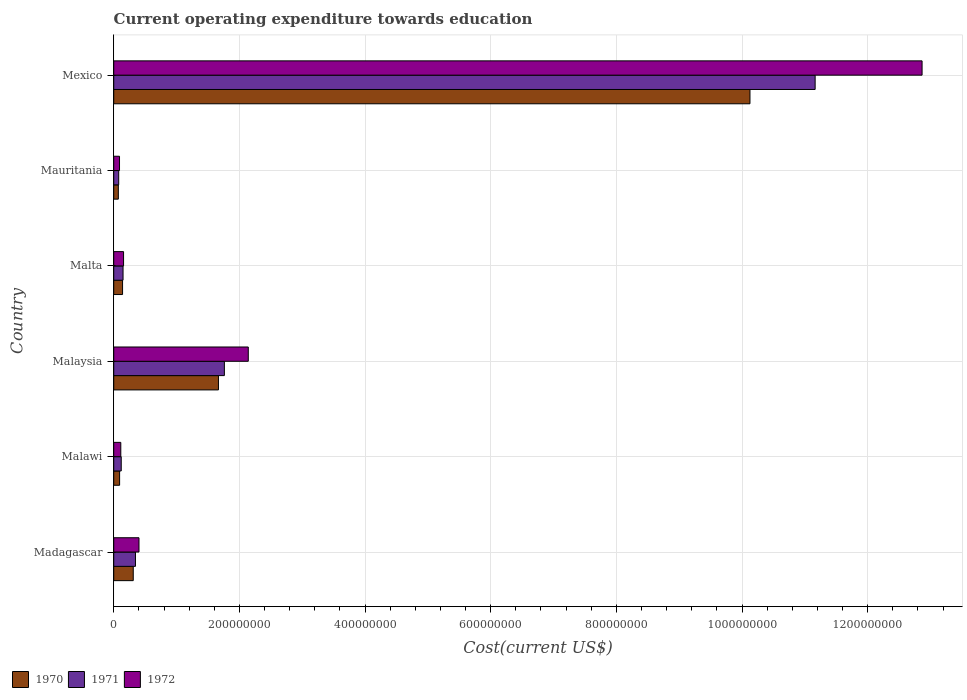How many different coloured bars are there?
Offer a very short reply. 3. Are the number of bars per tick equal to the number of legend labels?
Offer a very short reply. Yes. Are the number of bars on each tick of the Y-axis equal?
Your answer should be compact. Yes. What is the label of the 3rd group of bars from the top?
Keep it short and to the point. Malta. What is the expenditure towards education in 1971 in Malaysia?
Your answer should be very brief. 1.76e+08. Across all countries, what is the maximum expenditure towards education in 1970?
Offer a very short reply. 1.01e+09. Across all countries, what is the minimum expenditure towards education in 1971?
Give a very brief answer. 7.89e+06. In which country was the expenditure towards education in 1972 maximum?
Offer a very short reply. Mexico. In which country was the expenditure towards education in 1972 minimum?
Make the answer very short. Mauritania. What is the total expenditure towards education in 1970 in the graph?
Make the answer very short. 1.24e+09. What is the difference between the expenditure towards education in 1970 in Malaysia and that in Malta?
Keep it short and to the point. 1.53e+08. What is the difference between the expenditure towards education in 1971 in Malawi and the expenditure towards education in 1972 in Mauritania?
Ensure brevity in your answer.  2.73e+06. What is the average expenditure towards education in 1970 per country?
Offer a very short reply. 2.07e+08. What is the difference between the expenditure towards education in 1971 and expenditure towards education in 1972 in Mexico?
Your answer should be very brief. -1.70e+08. What is the ratio of the expenditure towards education in 1971 in Madagascar to that in Mauritania?
Your response must be concise. 4.38. Is the expenditure towards education in 1971 in Madagascar less than that in Malaysia?
Give a very brief answer. Yes. What is the difference between the highest and the second highest expenditure towards education in 1971?
Provide a short and direct response. 9.40e+08. What is the difference between the highest and the lowest expenditure towards education in 1970?
Give a very brief answer. 1.01e+09. Is the sum of the expenditure towards education in 1972 in Malaysia and Mexico greater than the maximum expenditure towards education in 1971 across all countries?
Provide a succinct answer. Yes. Is it the case that in every country, the sum of the expenditure towards education in 1971 and expenditure towards education in 1972 is greater than the expenditure towards education in 1970?
Make the answer very short. Yes. How many bars are there?
Offer a very short reply. 18. What is the difference between two consecutive major ticks on the X-axis?
Provide a short and direct response. 2.00e+08. Does the graph contain any zero values?
Your answer should be compact. No. Does the graph contain grids?
Provide a succinct answer. Yes. How are the legend labels stacked?
Give a very brief answer. Horizontal. What is the title of the graph?
Your response must be concise. Current operating expenditure towards education. Does "1973" appear as one of the legend labels in the graph?
Provide a succinct answer. No. What is the label or title of the X-axis?
Make the answer very short. Cost(current US$). What is the label or title of the Y-axis?
Make the answer very short. Country. What is the Cost(current US$) of 1970 in Madagascar?
Your answer should be very brief. 3.10e+07. What is the Cost(current US$) in 1971 in Madagascar?
Your answer should be very brief. 3.46e+07. What is the Cost(current US$) in 1972 in Madagascar?
Provide a short and direct response. 4.02e+07. What is the Cost(current US$) of 1970 in Malawi?
Your answer should be very brief. 9.35e+06. What is the Cost(current US$) in 1971 in Malawi?
Ensure brevity in your answer.  1.19e+07. What is the Cost(current US$) of 1972 in Malawi?
Ensure brevity in your answer.  1.12e+07. What is the Cost(current US$) in 1970 in Malaysia?
Ensure brevity in your answer.  1.67e+08. What is the Cost(current US$) of 1971 in Malaysia?
Your answer should be very brief. 1.76e+08. What is the Cost(current US$) of 1972 in Malaysia?
Provide a succinct answer. 2.14e+08. What is the Cost(current US$) in 1970 in Malta?
Your answer should be very brief. 1.40e+07. What is the Cost(current US$) of 1971 in Malta?
Your answer should be compact. 1.48e+07. What is the Cost(current US$) in 1972 in Malta?
Make the answer very short. 1.56e+07. What is the Cost(current US$) in 1970 in Mauritania?
Ensure brevity in your answer.  7.33e+06. What is the Cost(current US$) of 1971 in Mauritania?
Keep it short and to the point. 7.89e+06. What is the Cost(current US$) in 1972 in Mauritania?
Give a very brief answer. 9.19e+06. What is the Cost(current US$) in 1970 in Mexico?
Ensure brevity in your answer.  1.01e+09. What is the Cost(current US$) of 1971 in Mexico?
Keep it short and to the point. 1.12e+09. What is the Cost(current US$) in 1972 in Mexico?
Give a very brief answer. 1.29e+09. Across all countries, what is the maximum Cost(current US$) of 1970?
Your answer should be very brief. 1.01e+09. Across all countries, what is the maximum Cost(current US$) in 1971?
Provide a succinct answer. 1.12e+09. Across all countries, what is the maximum Cost(current US$) in 1972?
Provide a succinct answer. 1.29e+09. Across all countries, what is the minimum Cost(current US$) in 1970?
Your answer should be very brief. 7.33e+06. Across all countries, what is the minimum Cost(current US$) of 1971?
Ensure brevity in your answer.  7.89e+06. Across all countries, what is the minimum Cost(current US$) in 1972?
Offer a terse response. 9.19e+06. What is the total Cost(current US$) of 1970 in the graph?
Give a very brief answer. 1.24e+09. What is the total Cost(current US$) of 1971 in the graph?
Offer a very short reply. 1.36e+09. What is the total Cost(current US$) of 1972 in the graph?
Your response must be concise. 1.58e+09. What is the difference between the Cost(current US$) in 1970 in Madagascar and that in Malawi?
Your answer should be compact. 2.17e+07. What is the difference between the Cost(current US$) in 1971 in Madagascar and that in Malawi?
Your answer should be compact. 2.27e+07. What is the difference between the Cost(current US$) in 1972 in Madagascar and that in Malawi?
Provide a short and direct response. 2.89e+07. What is the difference between the Cost(current US$) in 1970 in Madagascar and that in Malaysia?
Offer a very short reply. -1.36e+08. What is the difference between the Cost(current US$) of 1971 in Madagascar and that in Malaysia?
Make the answer very short. -1.42e+08. What is the difference between the Cost(current US$) in 1972 in Madagascar and that in Malaysia?
Ensure brevity in your answer.  -1.74e+08. What is the difference between the Cost(current US$) in 1970 in Madagascar and that in Malta?
Keep it short and to the point. 1.70e+07. What is the difference between the Cost(current US$) of 1971 in Madagascar and that in Malta?
Give a very brief answer. 1.98e+07. What is the difference between the Cost(current US$) in 1972 in Madagascar and that in Malta?
Give a very brief answer. 2.45e+07. What is the difference between the Cost(current US$) of 1970 in Madagascar and that in Mauritania?
Give a very brief answer. 2.37e+07. What is the difference between the Cost(current US$) in 1971 in Madagascar and that in Mauritania?
Make the answer very short. 2.67e+07. What is the difference between the Cost(current US$) of 1972 in Madagascar and that in Mauritania?
Keep it short and to the point. 3.10e+07. What is the difference between the Cost(current US$) of 1970 in Madagascar and that in Mexico?
Ensure brevity in your answer.  -9.82e+08. What is the difference between the Cost(current US$) of 1971 in Madagascar and that in Mexico?
Offer a very short reply. -1.08e+09. What is the difference between the Cost(current US$) of 1972 in Madagascar and that in Mexico?
Provide a short and direct response. -1.25e+09. What is the difference between the Cost(current US$) of 1970 in Malawi and that in Malaysia?
Provide a short and direct response. -1.57e+08. What is the difference between the Cost(current US$) in 1971 in Malawi and that in Malaysia?
Keep it short and to the point. -1.64e+08. What is the difference between the Cost(current US$) in 1972 in Malawi and that in Malaysia?
Ensure brevity in your answer.  -2.03e+08. What is the difference between the Cost(current US$) in 1970 in Malawi and that in Malta?
Give a very brief answer. -4.69e+06. What is the difference between the Cost(current US$) in 1971 in Malawi and that in Malta?
Keep it short and to the point. -2.89e+06. What is the difference between the Cost(current US$) in 1972 in Malawi and that in Malta?
Keep it short and to the point. -4.40e+06. What is the difference between the Cost(current US$) of 1970 in Malawi and that in Mauritania?
Offer a very short reply. 2.02e+06. What is the difference between the Cost(current US$) of 1971 in Malawi and that in Mauritania?
Offer a terse response. 4.04e+06. What is the difference between the Cost(current US$) in 1972 in Malawi and that in Mauritania?
Keep it short and to the point. 2.05e+06. What is the difference between the Cost(current US$) in 1970 in Malawi and that in Mexico?
Ensure brevity in your answer.  -1.00e+09. What is the difference between the Cost(current US$) of 1971 in Malawi and that in Mexico?
Provide a succinct answer. -1.10e+09. What is the difference between the Cost(current US$) of 1972 in Malawi and that in Mexico?
Ensure brevity in your answer.  -1.28e+09. What is the difference between the Cost(current US$) of 1970 in Malaysia and that in Malta?
Give a very brief answer. 1.53e+08. What is the difference between the Cost(current US$) of 1971 in Malaysia and that in Malta?
Your response must be concise. 1.61e+08. What is the difference between the Cost(current US$) of 1972 in Malaysia and that in Malta?
Offer a very short reply. 1.98e+08. What is the difference between the Cost(current US$) in 1970 in Malaysia and that in Mauritania?
Provide a short and direct response. 1.59e+08. What is the difference between the Cost(current US$) of 1971 in Malaysia and that in Mauritania?
Your response must be concise. 1.68e+08. What is the difference between the Cost(current US$) in 1972 in Malaysia and that in Mauritania?
Give a very brief answer. 2.05e+08. What is the difference between the Cost(current US$) in 1970 in Malaysia and that in Mexico?
Offer a very short reply. -8.46e+08. What is the difference between the Cost(current US$) of 1971 in Malaysia and that in Mexico?
Give a very brief answer. -9.40e+08. What is the difference between the Cost(current US$) in 1972 in Malaysia and that in Mexico?
Provide a succinct answer. -1.07e+09. What is the difference between the Cost(current US$) of 1970 in Malta and that in Mauritania?
Provide a short and direct response. 6.71e+06. What is the difference between the Cost(current US$) of 1971 in Malta and that in Mauritania?
Make the answer very short. 6.93e+06. What is the difference between the Cost(current US$) in 1972 in Malta and that in Mauritania?
Your answer should be compact. 6.45e+06. What is the difference between the Cost(current US$) of 1970 in Malta and that in Mexico?
Give a very brief answer. -9.99e+08. What is the difference between the Cost(current US$) of 1971 in Malta and that in Mexico?
Ensure brevity in your answer.  -1.10e+09. What is the difference between the Cost(current US$) of 1972 in Malta and that in Mexico?
Make the answer very short. -1.27e+09. What is the difference between the Cost(current US$) in 1970 in Mauritania and that in Mexico?
Give a very brief answer. -1.01e+09. What is the difference between the Cost(current US$) of 1971 in Mauritania and that in Mexico?
Your answer should be compact. -1.11e+09. What is the difference between the Cost(current US$) of 1972 in Mauritania and that in Mexico?
Offer a very short reply. -1.28e+09. What is the difference between the Cost(current US$) of 1970 in Madagascar and the Cost(current US$) of 1971 in Malawi?
Ensure brevity in your answer.  1.91e+07. What is the difference between the Cost(current US$) of 1970 in Madagascar and the Cost(current US$) of 1972 in Malawi?
Your response must be concise. 1.98e+07. What is the difference between the Cost(current US$) of 1971 in Madagascar and the Cost(current US$) of 1972 in Malawi?
Your answer should be compact. 2.34e+07. What is the difference between the Cost(current US$) in 1970 in Madagascar and the Cost(current US$) in 1971 in Malaysia?
Provide a short and direct response. -1.45e+08. What is the difference between the Cost(current US$) of 1970 in Madagascar and the Cost(current US$) of 1972 in Malaysia?
Your answer should be very brief. -1.83e+08. What is the difference between the Cost(current US$) in 1971 in Madagascar and the Cost(current US$) in 1972 in Malaysia?
Provide a short and direct response. -1.80e+08. What is the difference between the Cost(current US$) in 1970 in Madagascar and the Cost(current US$) in 1971 in Malta?
Make the answer very short. 1.62e+07. What is the difference between the Cost(current US$) in 1970 in Madagascar and the Cost(current US$) in 1972 in Malta?
Offer a terse response. 1.54e+07. What is the difference between the Cost(current US$) of 1971 in Madagascar and the Cost(current US$) of 1972 in Malta?
Your answer should be compact. 1.90e+07. What is the difference between the Cost(current US$) of 1970 in Madagascar and the Cost(current US$) of 1971 in Mauritania?
Offer a very short reply. 2.32e+07. What is the difference between the Cost(current US$) of 1970 in Madagascar and the Cost(current US$) of 1972 in Mauritania?
Your response must be concise. 2.19e+07. What is the difference between the Cost(current US$) in 1971 in Madagascar and the Cost(current US$) in 1972 in Mauritania?
Your answer should be very brief. 2.54e+07. What is the difference between the Cost(current US$) in 1970 in Madagascar and the Cost(current US$) in 1971 in Mexico?
Make the answer very short. -1.09e+09. What is the difference between the Cost(current US$) of 1970 in Madagascar and the Cost(current US$) of 1972 in Mexico?
Your answer should be very brief. -1.26e+09. What is the difference between the Cost(current US$) in 1971 in Madagascar and the Cost(current US$) in 1972 in Mexico?
Keep it short and to the point. -1.25e+09. What is the difference between the Cost(current US$) of 1970 in Malawi and the Cost(current US$) of 1971 in Malaysia?
Give a very brief answer. -1.67e+08. What is the difference between the Cost(current US$) in 1970 in Malawi and the Cost(current US$) in 1972 in Malaysia?
Keep it short and to the point. -2.05e+08. What is the difference between the Cost(current US$) of 1971 in Malawi and the Cost(current US$) of 1972 in Malaysia?
Offer a very short reply. -2.02e+08. What is the difference between the Cost(current US$) of 1970 in Malawi and the Cost(current US$) of 1971 in Malta?
Your response must be concise. -5.47e+06. What is the difference between the Cost(current US$) of 1970 in Malawi and the Cost(current US$) of 1972 in Malta?
Make the answer very short. -6.29e+06. What is the difference between the Cost(current US$) in 1971 in Malawi and the Cost(current US$) in 1972 in Malta?
Give a very brief answer. -3.71e+06. What is the difference between the Cost(current US$) in 1970 in Malawi and the Cost(current US$) in 1971 in Mauritania?
Give a very brief answer. 1.46e+06. What is the difference between the Cost(current US$) in 1970 in Malawi and the Cost(current US$) in 1972 in Mauritania?
Give a very brief answer. 1.55e+05. What is the difference between the Cost(current US$) of 1971 in Malawi and the Cost(current US$) of 1972 in Mauritania?
Provide a succinct answer. 2.73e+06. What is the difference between the Cost(current US$) in 1970 in Malawi and the Cost(current US$) in 1971 in Mexico?
Provide a succinct answer. -1.11e+09. What is the difference between the Cost(current US$) of 1970 in Malawi and the Cost(current US$) of 1972 in Mexico?
Offer a terse response. -1.28e+09. What is the difference between the Cost(current US$) of 1971 in Malawi and the Cost(current US$) of 1972 in Mexico?
Offer a very short reply. -1.27e+09. What is the difference between the Cost(current US$) of 1970 in Malaysia and the Cost(current US$) of 1971 in Malta?
Your answer should be compact. 1.52e+08. What is the difference between the Cost(current US$) of 1970 in Malaysia and the Cost(current US$) of 1972 in Malta?
Provide a succinct answer. 1.51e+08. What is the difference between the Cost(current US$) of 1971 in Malaysia and the Cost(current US$) of 1972 in Malta?
Make the answer very short. 1.60e+08. What is the difference between the Cost(current US$) in 1970 in Malaysia and the Cost(current US$) in 1971 in Mauritania?
Make the answer very short. 1.59e+08. What is the difference between the Cost(current US$) of 1970 in Malaysia and the Cost(current US$) of 1972 in Mauritania?
Offer a terse response. 1.57e+08. What is the difference between the Cost(current US$) of 1971 in Malaysia and the Cost(current US$) of 1972 in Mauritania?
Make the answer very short. 1.67e+08. What is the difference between the Cost(current US$) of 1970 in Malaysia and the Cost(current US$) of 1971 in Mexico?
Your answer should be very brief. -9.50e+08. What is the difference between the Cost(current US$) of 1970 in Malaysia and the Cost(current US$) of 1972 in Mexico?
Give a very brief answer. -1.12e+09. What is the difference between the Cost(current US$) in 1971 in Malaysia and the Cost(current US$) in 1972 in Mexico?
Provide a succinct answer. -1.11e+09. What is the difference between the Cost(current US$) in 1970 in Malta and the Cost(current US$) in 1971 in Mauritania?
Provide a short and direct response. 6.15e+06. What is the difference between the Cost(current US$) in 1970 in Malta and the Cost(current US$) in 1972 in Mauritania?
Provide a succinct answer. 4.85e+06. What is the difference between the Cost(current US$) in 1971 in Malta and the Cost(current US$) in 1972 in Mauritania?
Offer a very short reply. 5.62e+06. What is the difference between the Cost(current US$) in 1970 in Malta and the Cost(current US$) in 1971 in Mexico?
Your response must be concise. -1.10e+09. What is the difference between the Cost(current US$) of 1970 in Malta and the Cost(current US$) of 1972 in Mexico?
Provide a short and direct response. -1.27e+09. What is the difference between the Cost(current US$) of 1971 in Malta and the Cost(current US$) of 1972 in Mexico?
Your response must be concise. -1.27e+09. What is the difference between the Cost(current US$) of 1970 in Mauritania and the Cost(current US$) of 1971 in Mexico?
Make the answer very short. -1.11e+09. What is the difference between the Cost(current US$) in 1970 in Mauritania and the Cost(current US$) in 1972 in Mexico?
Your response must be concise. -1.28e+09. What is the difference between the Cost(current US$) in 1971 in Mauritania and the Cost(current US$) in 1972 in Mexico?
Your answer should be compact. -1.28e+09. What is the average Cost(current US$) of 1970 per country?
Your answer should be very brief. 2.07e+08. What is the average Cost(current US$) in 1971 per country?
Offer a terse response. 2.27e+08. What is the average Cost(current US$) in 1972 per country?
Your answer should be compact. 2.63e+08. What is the difference between the Cost(current US$) in 1970 and Cost(current US$) in 1971 in Madagascar?
Make the answer very short. -3.55e+06. What is the difference between the Cost(current US$) of 1970 and Cost(current US$) of 1972 in Madagascar?
Offer a very short reply. -9.14e+06. What is the difference between the Cost(current US$) in 1971 and Cost(current US$) in 1972 in Madagascar?
Provide a short and direct response. -5.59e+06. What is the difference between the Cost(current US$) of 1970 and Cost(current US$) of 1971 in Malawi?
Your answer should be compact. -2.58e+06. What is the difference between the Cost(current US$) in 1970 and Cost(current US$) in 1972 in Malawi?
Your answer should be very brief. -1.89e+06. What is the difference between the Cost(current US$) of 1971 and Cost(current US$) of 1972 in Malawi?
Your response must be concise. 6.86e+05. What is the difference between the Cost(current US$) of 1970 and Cost(current US$) of 1971 in Malaysia?
Offer a terse response. -9.42e+06. What is the difference between the Cost(current US$) of 1970 and Cost(current US$) of 1972 in Malaysia?
Your answer should be very brief. -4.75e+07. What is the difference between the Cost(current US$) of 1971 and Cost(current US$) of 1972 in Malaysia?
Provide a short and direct response. -3.80e+07. What is the difference between the Cost(current US$) of 1970 and Cost(current US$) of 1971 in Malta?
Provide a short and direct response. -7.75e+05. What is the difference between the Cost(current US$) in 1970 and Cost(current US$) in 1972 in Malta?
Provide a succinct answer. -1.60e+06. What is the difference between the Cost(current US$) in 1971 and Cost(current US$) in 1972 in Malta?
Offer a terse response. -8.26e+05. What is the difference between the Cost(current US$) of 1970 and Cost(current US$) of 1971 in Mauritania?
Ensure brevity in your answer.  -5.63e+05. What is the difference between the Cost(current US$) of 1970 and Cost(current US$) of 1972 in Mauritania?
Give a very brief answer. -1.87e+06. What is the difference between the Cost(current US$) in 1971 and Cost(current US$) in 1972 in Mauritania?
Give a very brief answer. -1.30e+06. What is the difference between the Cost(current US$) in 1970 and Cost(current US$) in 1971 in Mexico?
Offer a terse response. -1.04e+08. What is the difference between the Cost(current US$) of 1970 and Cost(current US$) of 1972 in Mexico?
Provide a succinct answer. -2.74e+08. What is the difference between the Cost(current US$) in 1971 and Cost(current US$) in 1972 in Mexico?
Offer a very short reply. -1.70e+08. What is the ratio of the Cost(current US$) in 1970 in Madagascar to that in Malawi?
Give a very brief answer. 3.32. What is the ratio of the Cost(current US$) of 1971 in Madagascar to that in Malawi?
Keep it short and to the point. 2.9. What is the ratio of the Cost(current US$) in 1972 in Madagascar to that in Malawi?
Make the answer very short. 3.57. What is the ratio of the Cost(current US$) of 1970 in Madagascar to that in Malaysia?
Provide a succinct answer. 0.19. What is the ratio of the Cost(current US$) of 1971 in Madagascar to that in Malaysia?
Ensure brevity in your answer.  0.2. What is the ratio of the Cost(current US$) of 1972 in Madagascar to that in Malaysia?
Your answer should be very brief. 0.19. What is the ratio of the Cost(current US$) in 1970 in Madagascar to that in Malta?
Offer a terse response. 2.21. What is the ratio of the Cost(current US$) in 1971 in Madagascar to that in Malta?
Provide a short and direct response. 2.33. What is the ratio of the Cost(current US$) of 1972 in Madagascar to that in Malta?
Your answer should be compact. 2.57. What is the ratio of the Cost(current US$) of 1970 in Madagascar to that in Mauritania?
Your answer should be compact. 4.24. What is the ratio of the Cost(current US$) of 1971 in Madagascar to that in Mauritania?
Your response must be concise. 4.38. What is the ratio of the Cost(current US$) of 1972 in Madagascar to that in Mauritania?
Give a very brief answer. 4.37. What is the ratio of the Cost(current US$) in 1970 in Madagascar to that in Mexico?
Make the answer very short. 0.03. What is the ratio of the Cost(current US$) in 1971 in Madagascar to that in Mexico?
Your response must be concise. 0.03. What is the ratio of the Cost(current US$) in 1972 in Madagascar to that in Mexico?
Provide a short and direct response. 0.03. What is the ratio of the Cost(current US$) in 1970 in Malawi to that in Malaysia?
Make the answer very short. 0.06. What is the ratio of the Cost(current US$) in 1971 in Malawi to that in Malaysia?
Your response must be concise. 0.07. What is the ratio of the Cost(current US$) in 1972 in Malawi to that in Malaysia?
Offer a terse response. 0.05. What is the ratio of the Cost(current US$) in 1970 in Malawi to that in Malta?
Your answer should be very brief. 0.67. What is the ratio of the Cost(current US$) in 1971 in Malawi to that in Malta?
Offer a terse response. 0.81. What is the ratio of the Cost(current US$) of 1972 in Malawi to that in Malta?
Provide a succinct answer. 0.72. What is the ratio of the Cost(current US$) of 1970 in Malawi to that in Mauritania?
Your answer should be compact. 1.28. What is the ratio of the Cost(current US$) of 1971 in Malawi to that in Mauritania?
Your answer should be compact. 1.51. What is the ratio of the Cost(current US$) in 1972 in Malawi to that in Mauritania?
Keep it short and to the point. 1.22. What is the ratio of the Cost(current US$) in 1970 in Malawi to that in Mexico?
Your response must be concise. 0.01. What is the ratio of the Cost(current US$) in 1971 in Malawi to that in Mexico?
Your response must be concise. 0.01. What is the ratio of the Cost(current US$) of 1972 in Malawi to that in Mexico?
Provide a succinct answer. 0.01. What is the ratio of the Cost(current US$) in 1970 in Malaysia to that in Malta?
Keep it short and to the point. 11.87. What is the ratio of the Cost(current US$) in 1971 in Malaysia to that in Malta?
Offer a terse response. 11.89. What is the ratio of the Cost(current US$) in 1972 in Malaysia to that in Malta?
Offer a very short reply. 13.69. What is the ratio of the Cost(current US$) in 1970 in Malaysia to that in Mauritania?
Ensure brevity in your answer.  22.75. What is the ratio of the Cost(current US$) of 1971 in Malaysia to that in Mauritania?
Ensure brevity in your answer.  22.32. What is the ratio of the Cost(current US$) in 1972 in Malaysia to that in Mauritania?
Offer a very short reply. 23.29. What is the ratio of the Cost(current US$) in 1970 in Malaysia to that in Mexico?
Provide a succinct answer. 0.16. What is the ratio of the Cost(current US$) in 1971 in Malaysia to that in Mexico?
Provide a succinct answer. 0.16. What is the ratio of the Cost(current US$) in 1972 in Malaysia to that in Mexico?
Keep it short and to the point. 0.17. What is the ratio of the Cost(current US$) of 1970 in Malta to that in Mauritania?
Give a very brief answer. 1.92. What is the ratio of the Cost(current US$) in 1971 in Malta to that in Mauritania?
Offer a very short reply. 1.88. What is the ratio of the Cost(current US$) in 1972 in Malta to that in Mauritania?
Offer a terse response. 1.7. What is the ratio of the Cost(current US$) of 1970 in Malta to that in Mexico?
Make the answer very short. 0.01. What is the ratio of the Cost(current US$) in 1971 in Malta to that in Mexico?
Your response must be concise. 0.01. What is the ratio of the Cost(current US$) of 1972 in Malta to that in Mexico?
Give a very brief answer. 0.01. What is the ratio of the Cost(current US$) of 1970 in Mauritania to that in Mexico?
Provide a short and direct response. 0.01. What is the ratio of the Cost(current US$) of 1971 in Mauritania to that in Mexico?
Keep it short and to the point. 0.01. What is the ratio of the Cost(current US$) in 1972 in Mauritania to that in Mexico?
Your answer should be very brief. 0.01. What is the difference between the highest and the second highest Cost(current US$) in 1970?
Provide a short and direct response. 8.46e+08. What is the difference between the highest and the second highest Cost(current US$) in 1971?
Your response must be concise. 9.40e+08. What is the difference between the highest and the second highest Cost(current US$) in 1972?
Your answer should be compact. 1.07e+09. What is the difference between the highest and the lowest Cost(current US$) of 1970?
Your answer should be very brief. 1.01e+09. What is the difference between the highest and the lowest Cost(current US$) of 1971?
Offer a very short reply. 1.11e+09. What is the difference between the highest and the lowest Cost(current US$) of 1972?
Your answer should be very brief. 1.28e+09. 